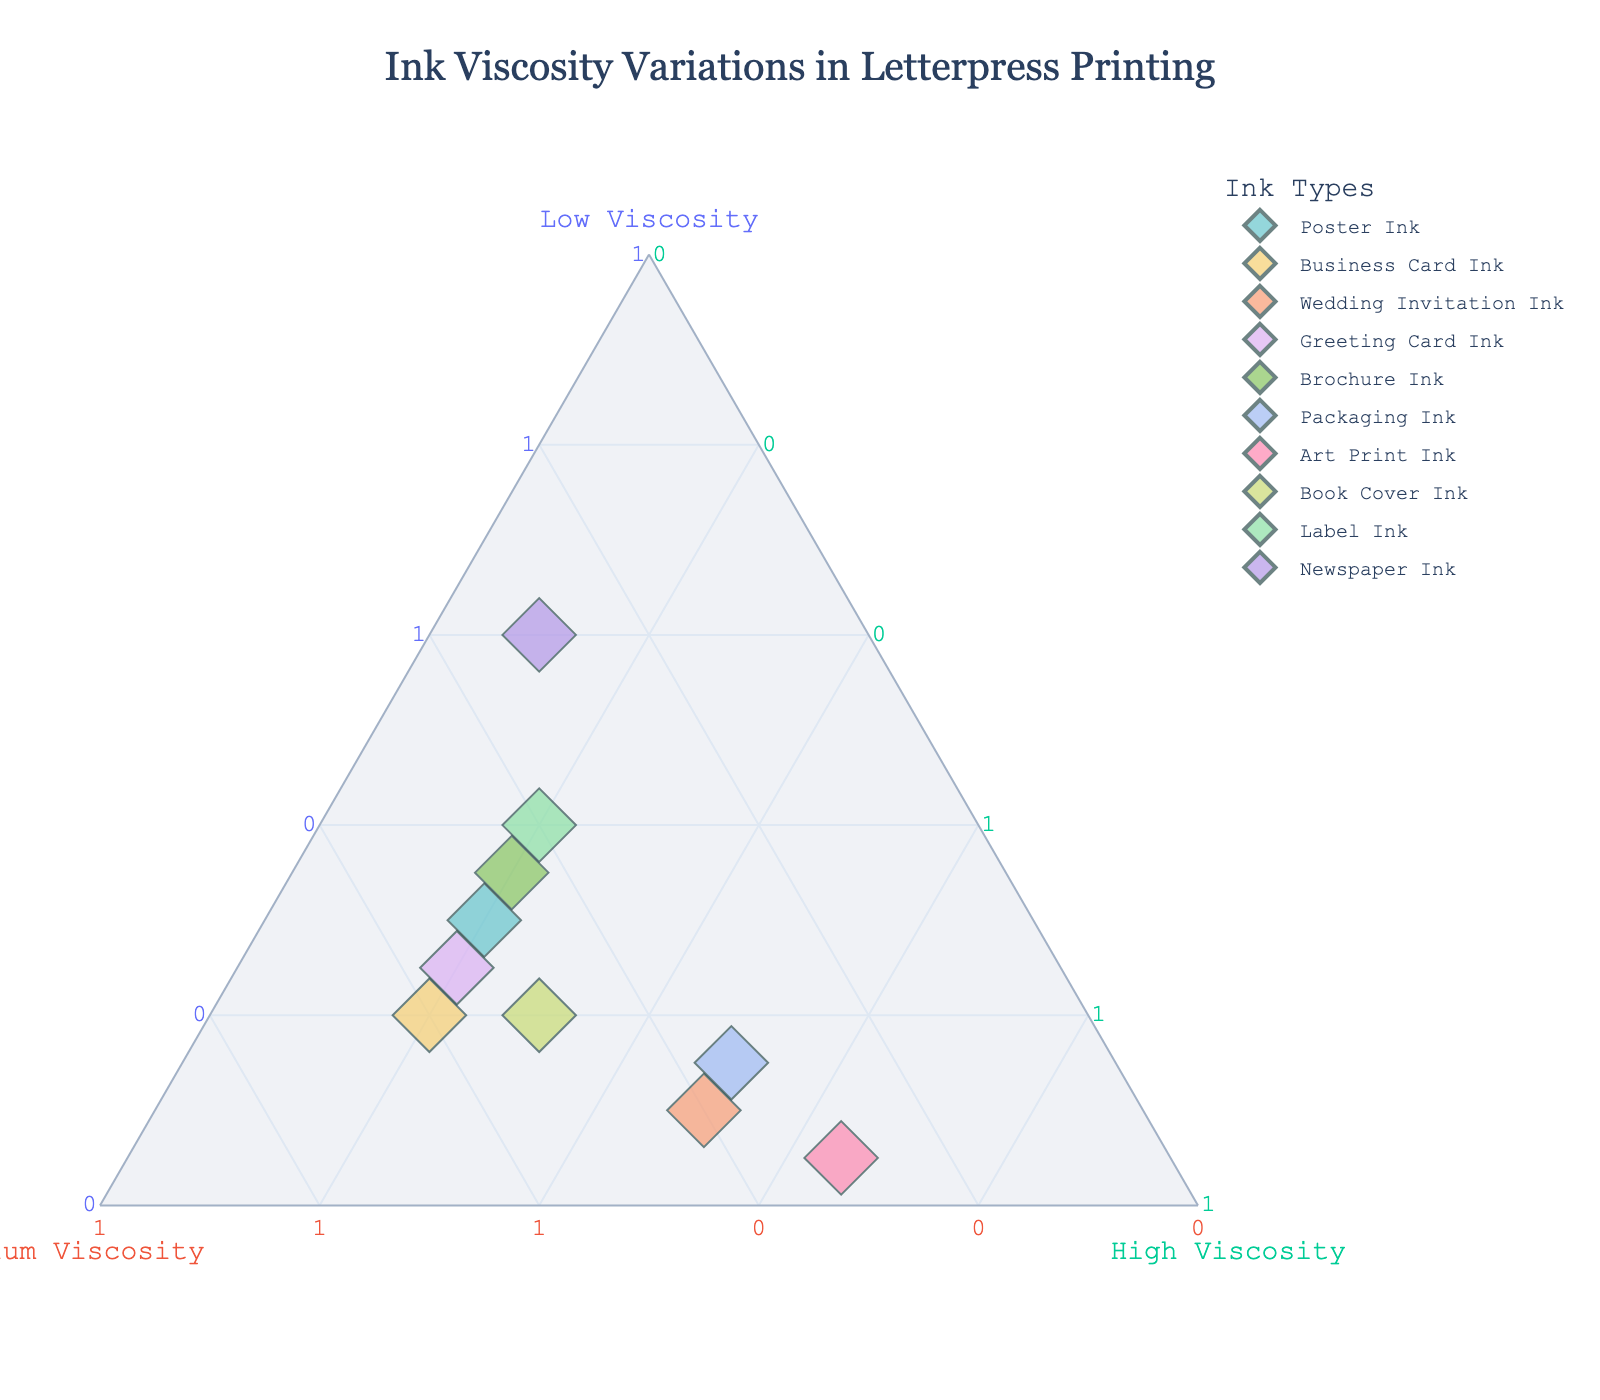What is the title of the ternary plot? The title of the ternary plot is positioned at the top center of the figure. It is usually a descriptive phrase that summarizes the main theme or subject of the plot.
Answer: "Ink Viscosity Variations in Letterpress Printing" How many different types of ink are displayed in the plot? By looking at the legend or the number of distinct points in the ternary plot, one can see how many types of ink are represented.
Answer: 10 Which ink type has the highest percentage of low viscosity ink? Examine each data point to find the one closest to the Low Viscosity axis. In this case, it will have the largest value for the low viscosity component.
Answer: Newspaper Ink Which ink type has an equal distribution of medium and high viscosity inks? Find the data point where the values for medium viscosity and high viscosity are equal. This can be observed directly by checking the hover information on the plot.
Answer: Label Ink What is the color used for marking each ink type on the ternary plot? By looking at the legend and the markers in the plot, we can identify the colors used for each ink type to aid in understanding the distribution and category of each point.
Answer: Pastel colors What is the ratio of low to medium viscosity in the Poster Ink? Retrieve the individual percentages for low and medium viscosity in the Poster Ink, then compute the ratio by dividing low viscosity by medium viscosity.
Answer: 30/50 or 3/5 Which ink type is predominantly high viscosity? Identify the data point that is nearest to the High Viscosity axis, indicating it has the highest proportion of high viscosity ink.
Answer: Art Print Ink What's the average percentage of medium viscosity ink for Greeting Card Ink and Brochure Ink? Add the percentage of medium viscosity ink for both ink types and then divide by two to get the average. (Greeting Card Ink: 55%, Brochure Ink: 45%)
Answer: (55+45)/2 = 50% Which ink types have a low viscosity percentage greater than 25%? Identify the data points whose low viscosity percentage exceeds 25% by examining their positions on the plot.
Answer: Poster Ink, Brochure Ink, Label Ink, Newspaper Ink Which ink type has the largest variance in viscosity distribution? Find the data point with the most diverse values across low, medium, and high viscosity by looking at how spread out the percentages are from the average value of 33.33%.
Answer: Art Print Ink 